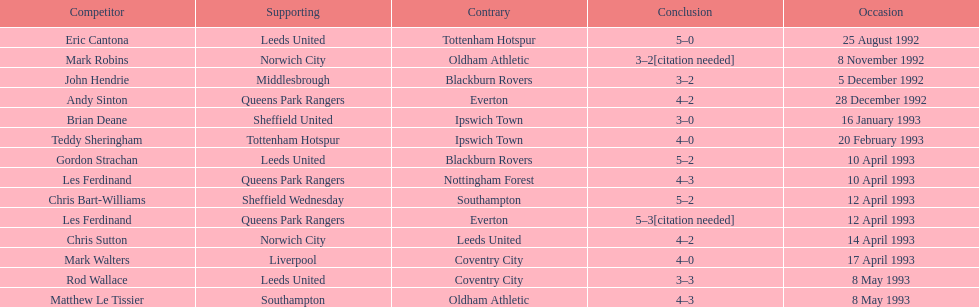In the 1992-1993 premier league, what was the total number of hat tricks scored by all players? 14. 